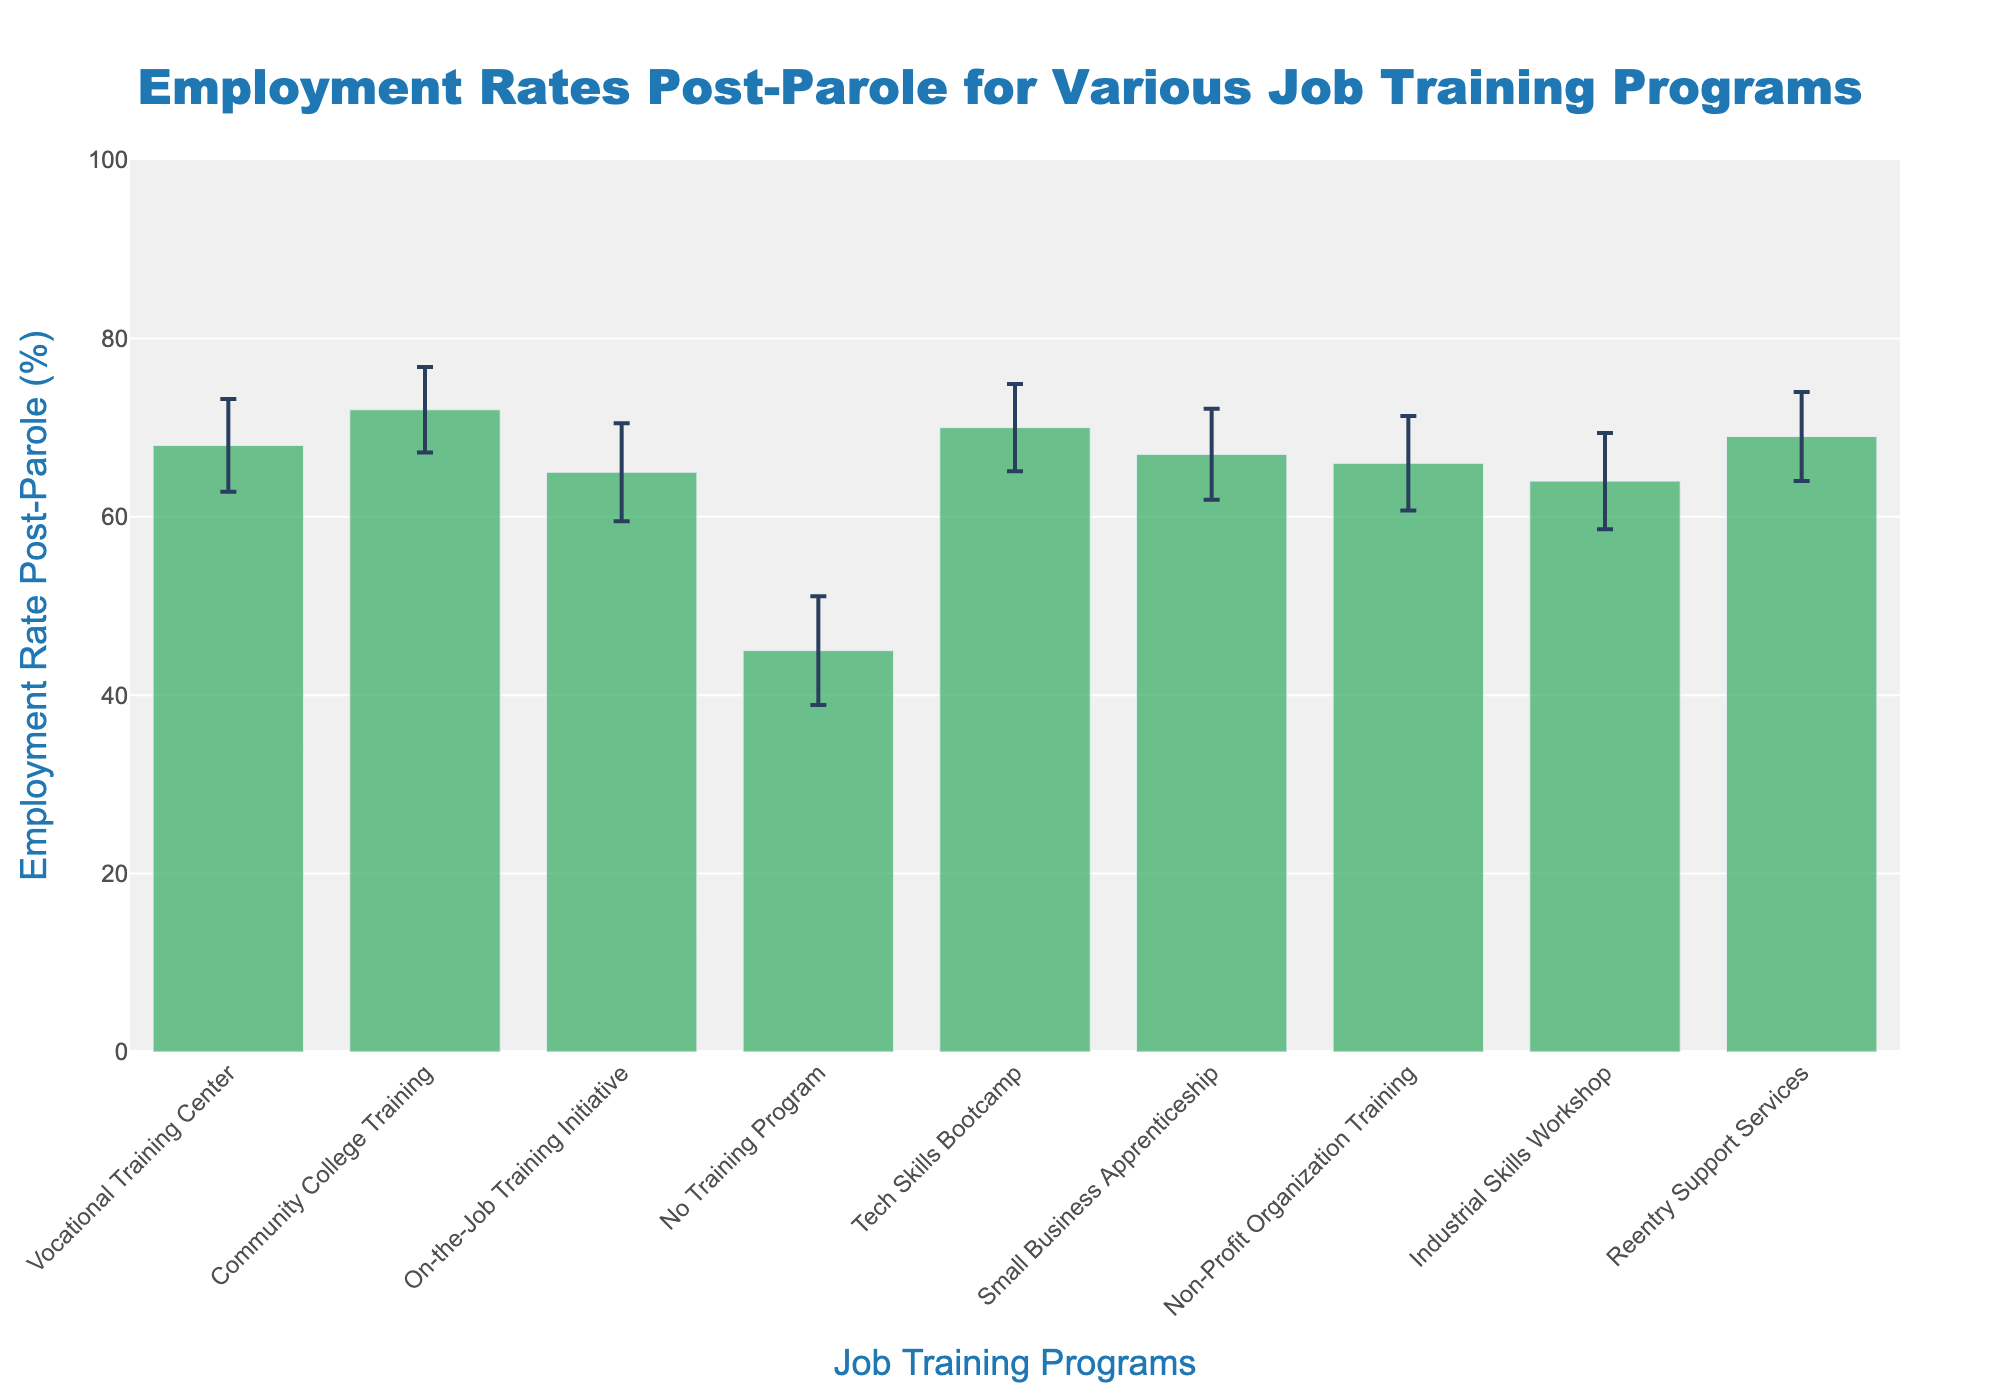What is the title of the figure? The title of the figure is displayed prominently at the top. It states "Employment Rates Post-Parole for Various Job Training Programs".
Answer: Employment Rates Post-Parole for Various Job Training Programs What is the employment rate post-parole for individuals engaged in the Community College Training program? The employment rate for the Community College Training program is indicated by the bar labeled "Community College Training". The bar's height corresponds to the employment rate value on the y-axis, which shows 72%.
Answer: 72% Which job training program has the lowest employment rate post-parole? By observing the height of each bar, we can determine that the "No Training Program" has the lowest employment rate post-parole at 45%, as it is significantly lower than the other programs.
Answer: No Training Program What is the standard deviation for the Tech Skills Bootcamp program? The error bars represent the standard deviation for each program, and the figure’s hovertext reveals that the standard deviation for the Tech Skills Bootcamp program is 4.9.
Answer: 4.9 How many job training programs are shown in the figure? The figure includes different job training programs. Counting each bar labeled as a program, we find there are 9 distinct programs featured.
Answer: 9 What is the average employment rate post-parole for programs excluding the No Training Program? First, list the employment rates of the other programs: 68, 72, 65, 70, 67, 66, 64, 69. Sum these rates: 68+72+65+70+67+66+64+69 = 541. Divide by the number of programs: 541/8 = 67.625.
Answer: 67.625 Which program has the highest standard deviation in employment rate post-parole? By reviewing the error bars for variations and referencing the hovertext, the "No Training Program" has the highest standard deviation of 6.1.
Answer: No Training Program By how much does the employment rate post-parole increase for Community College Training compared to No Training Program? The employment rate for Community College Training is 72%, and for No Training Program it is 45%. The increase is therefore 72% - 45% = 27%.
Answer: 27% What is the range of employment rates post-parole among all the programs? The highest employment rate is 72% (Community College Training) and the lowest is 45% (No Training Program). The range is therefore 72% - 45% = 27%.
Answer: 27% Is the employment rate post-parole higher for individuals involved in Reentry Support Services or Small Business Apprenticeship? The employment rate for Reentry Support Services is 69%, and for Small Business Apprenticeship it is 67%. Therefore, the rate is higher for Reentry Support Services.
Answer: Reentry Support Services 